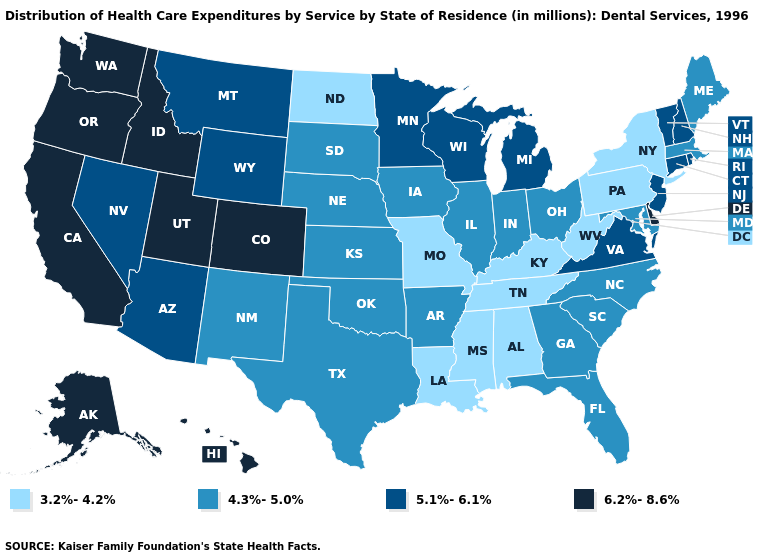Name the states that have a value in the range 6.2%-8.6%?
Short answer required. Alaska, California, Colorado, Delaware, Hawaii, Idaho, Oregon, Utah, Washington. Name the states that have a value in the range 3.2%-4.2%?
Give a very brief answer. Alabama, Kentucky, Louisiana, Mississippi, Missouri, New York, North Dakota, Pennsylvania, Tennessee, West Virginia. What is the value of Florida?
Keep it brief. 4.3%-5.0%. Which states have the highest value in the USA?
Concise answer only. Alaska, California, Colorado, Delaware, Hawaii, Idaho, Oregon, Utah, Washington. Name the states that have a value in the range 4.3%-5.0%?
Be succinct. Arkansas, Florida, Georgia, Illinois, Indiana, Iowa, Kansas, Maine, Maryland, Massachusetts, Nebraska, New Mexico, North Carolina, Ohio, Oklahoma, South Carolina, South Dakota, Texas. Which states have the lowest value in the South?
Quick response, please. Alabama, Kentucky, Louisiana, Mississippi, Tennessee, West Virginia. How many symbols are there in the legend?
Keep it brief. 4. What is the lowest value in the USA?
Give a very brief answer. 3.2%-4.2%. Name the states that have a value in the range 4.3%-5.0%?
Keep it brief. Arkansas, Florida, Georgia, Illinois, Indiana, Iowa, Kansas, Maine, Maryland, Massachusetts, Nebraska, New Mexico, North Carolina, Ohio, Oklahoma, South Carolina, South Dakota, Texas. Name the states that have a value in the range 5.1%-6.1%?
Answer briefly. Arizona, Connecticut, Michigan, Minnesota, Montana, Nevada, New Hampshire, New Jersey, Rhode Island, Vermont, Virginia, Wisconsin, Wyoming. Name the states that have a value in the range 6.2%-8.6%?
Answer briefly. Alaska, California, Colorado, Delaware, Hawaii, Idaho, Oregon, Utah, Washington. Is the legend a continuous bar?
Quick response, please. No. What is the value of Washington?
Be succinct. 6.2%-8.6%. Name the states that have a value in the range 5.1%-6.1%?
Keep it brief. Arizona, Connecticut, Michigan, Minnesota, Montana, Nevada, New Hampshire, New Jersey, Rhode Island, Vermont, Virginia, Wisconsin, Wyoming. What is the highest value in states that border Rhode Island?
Short answer required. 5.1%-6.1%. 